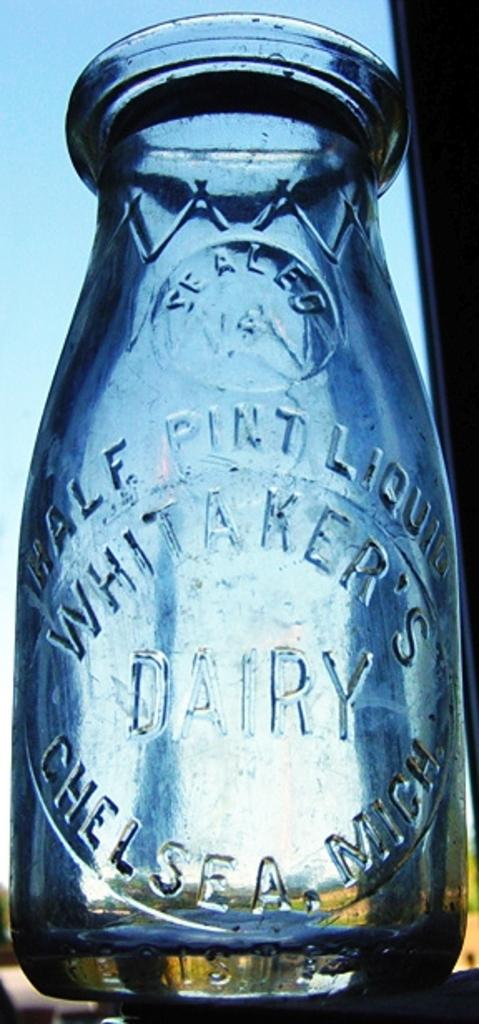<image>
Create a compact narrative representing the image presented. A milk jug from the Whitaker's dairy company 